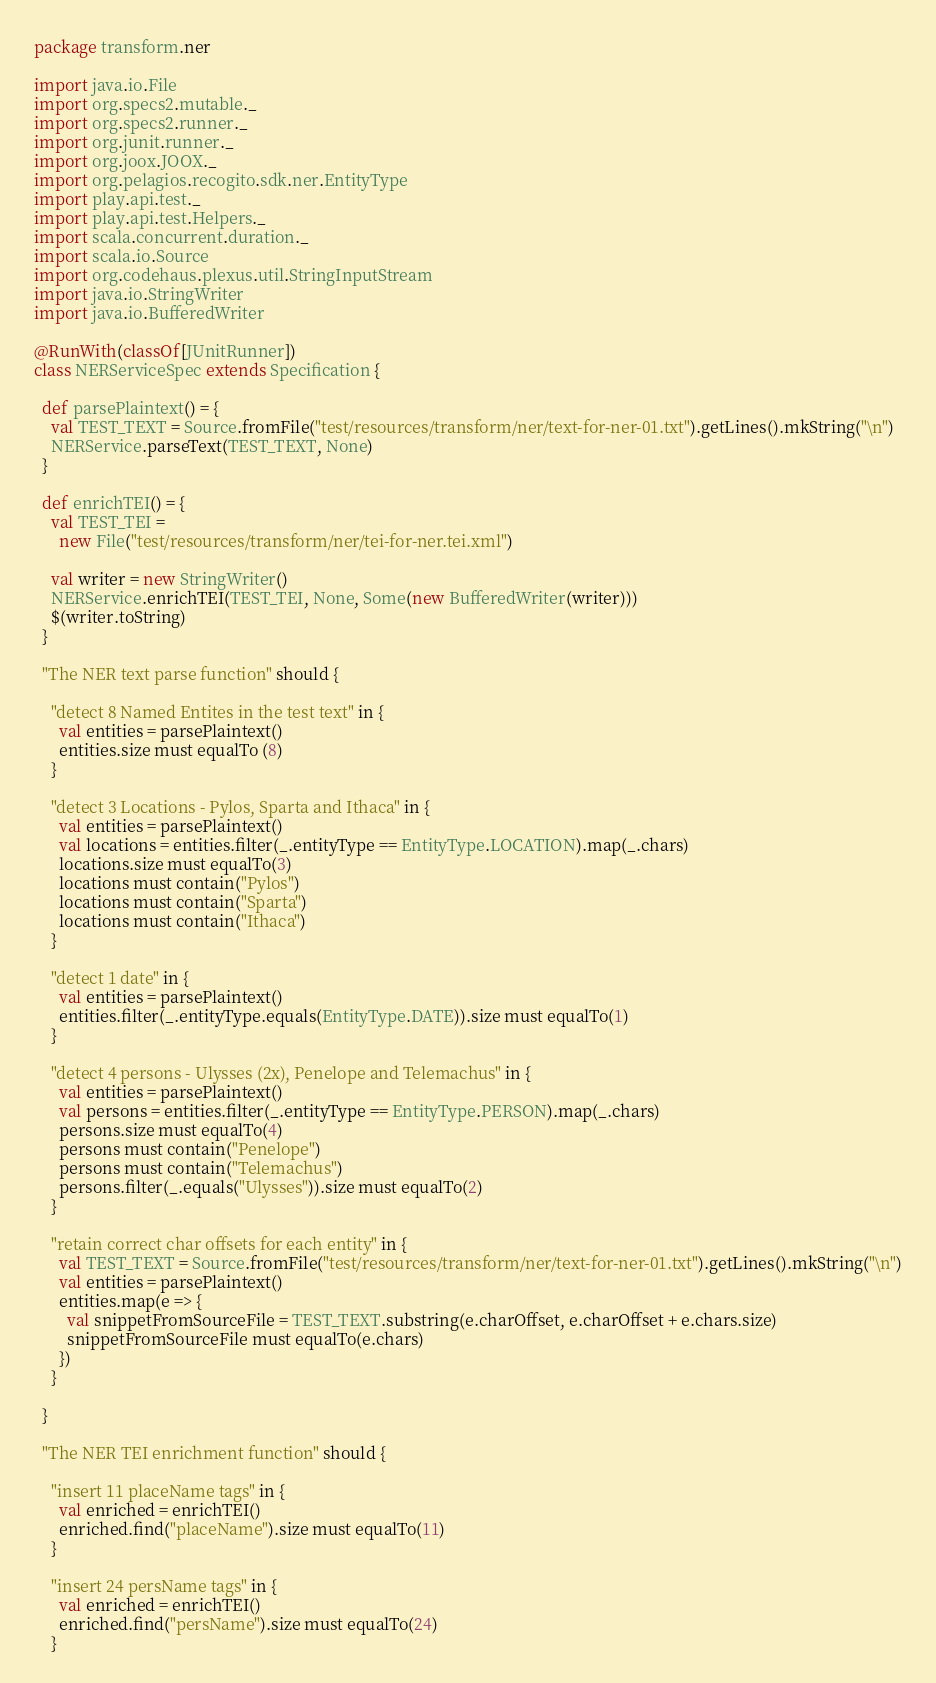<code> <loc_0><loc_0><loc_500><loc_500><_Scala_>package transform.ner

import java.io.File
import org.specs2.mutable._
import org.specs2.runner._
import org.junit.runner._
import org.joox.JOOX._
import org.pelagios.recogito.sdk.ner.EntityType
import play.api.test._
import play.api.test.Helpers._
import scala.concurrent.duration._
import scala.io.Source
import org.codehaus.plexus.util.StringInputStream
import java.io.StringWriter
import java.io.BufferedWriter

@RunWith(classOf[JUnitRunner])
class NERServiceSpec extends Specification {

  def parsePlaintext() = {
    val TEST_TEXT = Source.fromFile("test/resources/transform/ner/text-for-ner-01.txt").getLines().mkString("\n")
    NERService.parseText(TEST_TEXT, None)
  }
  
  def enrichTEI() = {
    val TEST_TEI = 
      new File("test/resources/transform/ner/tei-for-ner.tei.xml")
    
    val writer = new StringWriter()
    NERService.enrichTEI(TEST_TEI, None, Some(new BufferedWriter(writer)))
    $(writer.toString)
  }

  "The NER text parse function" should {
      
    "detect 8 Named Entites in the test text" in {
      val entities = parsePlaintext()
      entities.size must equalTo (8)
    }

    "detect 3 Locations - Pylos, Sparta and Ithaca" in {
      val entities = parsePlaintext()
      val locations = entities.filter(_.entityType == EntityType.LOCATION).map(_.chars)
      locations.size must equalTo(3)
      locations must contain("Pylos")
      locations must contain("Sparta")
      locations must contain("Ithaca")
    }

    "detect 1 date" in {
      val entities = parsePlaintext()
      entities.filter(_.entityType.equals(EntityType.DATE)).size must equalTo(1)
    }

    "detect 4 persons - Ulysses (2x), Penelope and Telemachus" in {
      val entities = parsePlaintext()
      val persons = entities.filter(_.entityType == EntityType.PERSON).map(_.chars)
      persons.size must equalTo(4)
      persons must contain("Penelope")
      persons must contain("Telemachus")
      persons.filter(_.equals("Ulysses")).size must equalTo(2)
    }

    "retain correct char offsets for each entity" in {
      val TEST_TEXT = Source.fromFile("test/resources/transform/ner/text-for-ner-01.txt").getLines().mkString("\n")
      val entities = parsePlaintext()
      entities.map(e => {
        val snippetFromSourceFile = TEST_TEXT.substring(e.charOffset, e.charOffset + e.chars.size)
        snippetFromSourceFile must equalTo(e.chars)
      })
    }

  }
  
  "The NER TEI enrichment function" should {
        
    "insert 11 placeName tags" in {
      val enriched = enrichTEI()
      enriched.find("placeName").size must equalTo(11) 
    }
    
    "insert 24 persName tags" in {
      val enriched = enrichTEI()
      enriched.find("persName").size must equalTo(24)       
    }</code> 